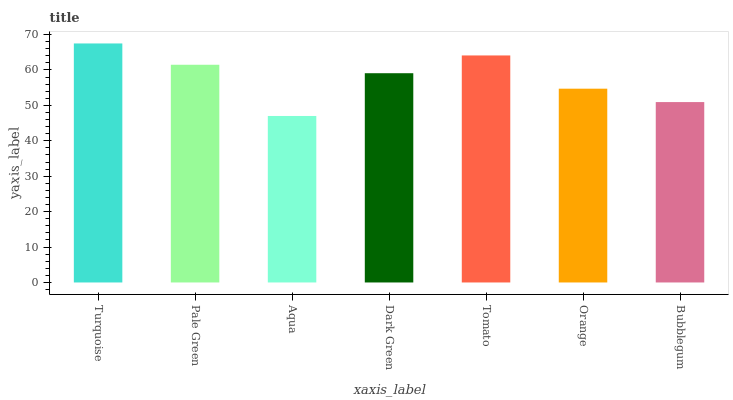Is Aqua the minimum?
Answer yes or no. Yes. Is Turquoise the maximum?
Answer yes or no. Yes. Is Pale Green the minimum?
Answer yes or no. No. Is Pale Green the maximum?
Answer yes or no. No. Is Turquoise greater than Pale Green?
Answer yes or no. Yes. Is Pale Green less than Turquoise?
Answer yes or no. Yes. Is Pale Green greater than Turquoise?
Answer yes or no. No. Is Turquoise less than Pale Green?
Answer yes or no. No. Is Dark Green the high median?
Answer yes or no. Yes. Is Dark Green the low median?
Answer yes or no. Yes. Is Turquoise the high median?
Answer yes or no. No. Is Orange the low median?
Answer yes or no. No. 